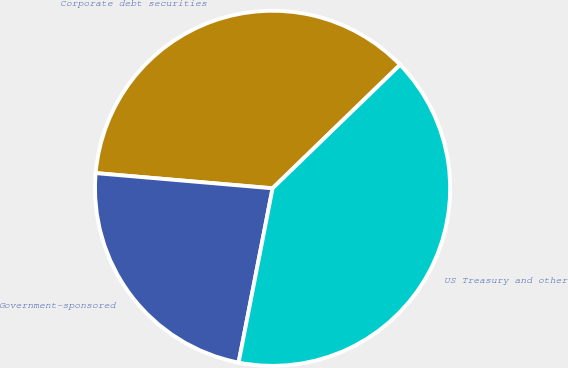Convert chart to OTSL. <chart><loc_0><loc_0><loc_500><loc_500><pie_chart><fcel>Corporate debt securities<fcel>Government-sponsored<fcel>US Treasury and other<nl><fcel>36.39%<fcel>23.3%<fcel>40.31%<nl></chart> 